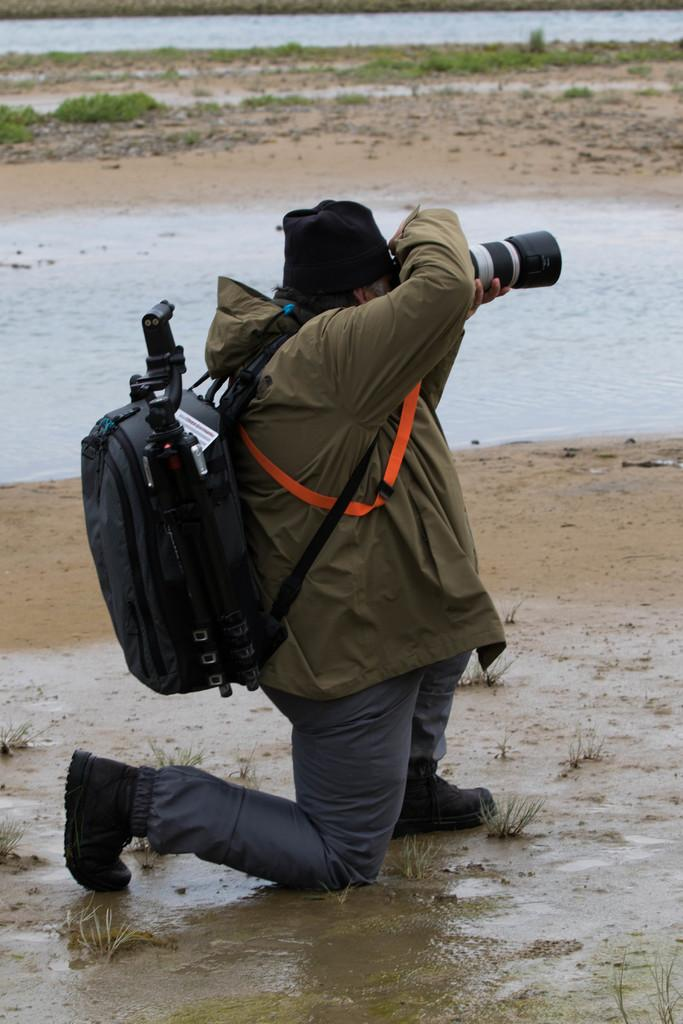What is the person in the image doing? The person in the image is holding a camera. What is the person wearing that might be used for carrying items? The person is wearing a bag. What can be seen in the background of the image? There is water and grasses visible in the background of the image. How many trees can be seen growing inside the cave in the image? There is no cave or trees present in the image. What type of pickle is being used as a prop in the image? There is no pickle present in the image. 